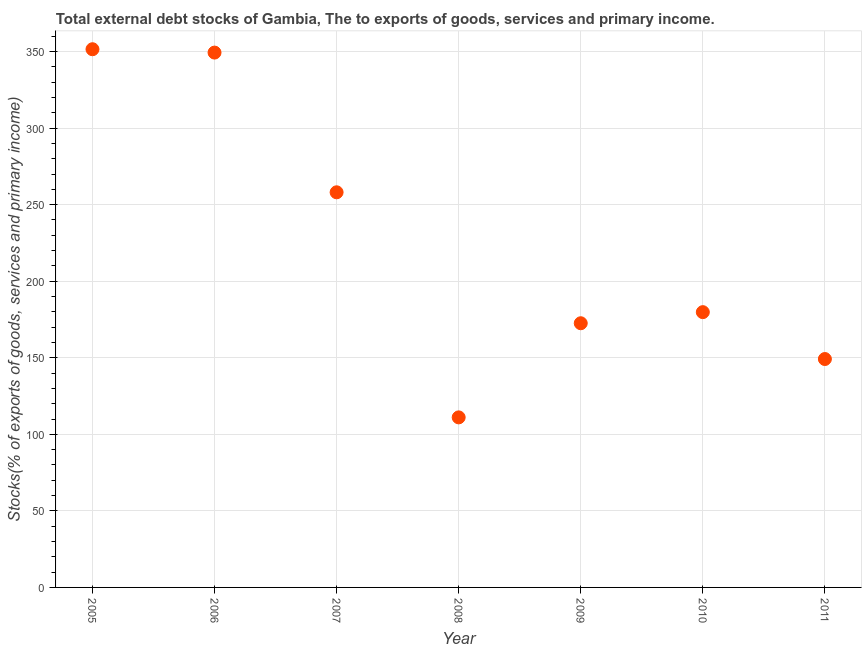What is the external debt stocks in 2009?
Offer a very short reply. 172.55. Across all years, what is the maximum external debt stocks?
Provide a succinct answer. 351.52. Across all years, what is the minimum external debt stocks?
Your response must be concise. 111.07. What is the sum of the external debt stocks?
Make the answer very short. 1571.53. What is the difference between the external debt stocks in 2005 and 2011?
Offer a terse response. 202.34. What is the average external debt stocks per year?
Keep it short and to the point. 224.5. What is the median external debt stocks?
Make the answer very short. 179.8. In how many years, is the external debt stocks greater than 90 %?
Offer a very short reply. 7. What is the ratio of the external debt stocks in 2009 to that in 2011?
Give a very brief answer. 1.16. Is the external debt stocks in 2010 less than that in 2011?
Your answer should be compact. No. What is the difference between the highest and the second highest external debt stocks?
Offer a very short reply. 2.19. What is the difference between the highest and the lowest external debt stocks?
Your response must be concise. 240.45. In how many years, is the external debt stocks greater than the average external debt stocks taken over all years?
Keep it short and to the point. 3. Does the external debt stocks monotonically increase over the years?
Your answer should be very brief. No. How many years are there in the graph?
Your answer should be compact. 7. Does the graph contain grids?
Give a very brief answer. Yes. What is the title of the graph?
Give a very brief answer. Total external debt stocks of Gambia, The to exports of goods, services and primary income. What is the label or title of the Y-axis?
Offer a terse response. Stocks(% of exports of goods, services and primary income). What is the Stocks(% of exports of goods, services and primary income) in 2005?
Give a very brief answer. 351.52. What is the Stocks(% of exports of goods, services and primary income) in 2006?
Keep it short and to the point. 349.33. What is the Stocks(% of exports of goods, services and primary income) in 2007?
Keep it short and to the point. 258.08. What is the Stocks(% of exports of goods, services and primary income) in 2008?
Give a very brief answer. 111.07. What is the Stocks(% of exports of goods, services and primary income) in 2009?
Your answer should be compact. 172.55. What is the Stocks(% of exports of goods, services and primary income) in 2010?
Your response must be concise. 179.8. What is the Stocks(% of exports of goods, services and primary income) in 2011?
Your answer should be very brief. 149.18. What is the difference between the Stocks(% of exports of goods, services and primary income) in 2005 and 2006?
Give a very brief answer. 2.19. What is the difference between the Stocks(% of exports of goods, services and primary income) in 2005 and 2007?
Make the answer very short. 93.44. What is the difference between the Stocks(% of exports of goods, services and primary income) in 2005 and 2008?
Your answer should be compact. 240.45. What is the difference between the Stocks(% of exports of goods, services and primary income) in 2005 and 2009?
Give a very brief answer. 178.97. What is the difference between the Stocks(% of exports of goods, services and primary income) in 2005 and 2010?
Ensure brevity in your answer.  171.73. What is the difference between the Stocks(% of exports of goods, services and primary income) in 2005 and 2011?
Your response must be concise. 202.34. What is the difference between the Stocks(% of exports of goods, services and primary income) in 2006 and 2007?
Your answer should be very brief. 91.25. What is the difference between the Stocks(% of exports of goods, services and primary income) in 2006 and 2008?
Keep it short and to the point. 238.26. What is the difference between the Stocks(% of exports of goods, services and primary income) in 2006 and 2009?
Offer a terse response. 176.78. What is the difference between the Stocks(% of exports of goods, services and primary income) in 2006 and 2010?
Your answer should be very brief. 169.53. What is the difference between the Stocks(% of exports of goods, services and primary income) in 2006 and 2011?
Your answer should be compact. 200.15. What is the difference between the Stocks(% of exports of goods, services and primary income) in 2007 and 2008?
Keep it short and to the point. 147.01. What is the difference between the Stocks(% of exports of goods, services and primary income) in 2007 and 2009?
Ensure brevity in your answer.  85.53. What is the difference between the Stocks(% of exports of goods, services and primary income) in 2007 and 2010?
Provide a succinct answer. 78.28. What is the difference between the Stocks(% of exports of goods, services and primary income) in 2007 and 2011?
Offer a terse response. 108.9. What is the difference between the Stocks(% of exports of goods, services and primary income) in 2008 and 2009?
Your response must be concise. -61.48. What is the difference between the Stocks(% of exports of goods, services and primary income) in 2008 and 2010?
Provide a succinct answer. -68.73. What is the difference between the Stocks(% of exports of goods, services and primary income) in 2008 and 2011?
Your answer should be compact. -38.11. What is the difference between the Stocks(% of exports of goods, services and primary income) in 2009 and 2010?
Give a very brief answer. -7.25. What is the difference between the Stocks(% of exports of goods, services and primary income) in 2009 and 2011?
Offer a terse response. 23.37. What is the difference between the Stocks(% of exports of goods, services and primary income) in 2010 and 2011?
Give a very brief answer. 30.61. What is the ratio of the Stocks(% of exports of goods, services and primary income) in 2005 to that in 2007?
Keep it short and to the point. 1.36. What is the ratio of the Stocks(% of exports of goods, services and primary income) in 2005 to that in 2008?
Make the answer very short. 3.17. What is the ratio of the Stocks(% of exports of goods, services and primary income) in 2005 to that in 2009?
Offer a very short reply. 2.04. What is the ratio of the Stocks(% of exports of goods, services and primary income) in 2005 to that in 2010?
Keep it short and to the point. 1.96. What is the ratio of the Stocks(% of exports of goods, services and primary income) in 2005 to that in 2011?
Provide a short and direct response. 2.36. What is the ratio of the Stocks(% of exports of goods, services and primary income) in 2006 to that in 2007?
Offer a terse response. 1.35. What is the ratio of the Stocks(% of exports of goods, services and primary income) in 2006 to that in 2008?
Offer a terse response. 3.15. What is the ratio of the Stocks(% of exports of goods, services and primary income) in 2006 to that in 2009?
Offer a very short reply. 2.02. What is the ratio of the Stocks(% of exports of goods, services and primary income) in 2006 to that in 2010?
Give a very brief answer. 1.94. What is the ratio of the Stocks(% of exports of goods, services and primary income) in 2006 to that in 2011?
Provide a succinct answer. 2.34. What is the ratio of the Stocks(% of exports of goods, services and primary income) in 2007 to that in 2008?
Your answer should be compact. 2.32. What is the ratio of the Stocks(% of exports of goods, services and primary income) in 2007 to that in 2009?
Your response must be concise. 1.5. What is the ratio of the Stocks(% of exports of goods, services and primary income) in 2007 to that in 2010?
Provide a short and direct response. 1.44. What is the ratio of the Stocks(% of exports of goods, services and primary income) in 2007 to that in 2011?
Ensure brevity in your answer.  1.73. What is the ratio of the Stocks(% of exports of goods, services and primary income) in 2008 to that in 2009?
Your answer should be compact. 0.64. What is the ratio of the Stocks(% of exports of goods, services and primary income) in 2008 to that in 2010?
Make the answer very short. 0.62. What is the ratio of the Stocks(% of exports of goods, services and primary income) in 2008 to that in 2011?
Your answer should be very brief. 0.74. What is the ratio of the Stocks(% of exports of goods, services and primary income) in 2009 to that in 2011?
Give a very brief answer. 1.16. What is the ratio of the Stocks(% of exports of goods, services and primary income) in 2010 to that in 2011?
Provide a short and direct response. 1.21. 